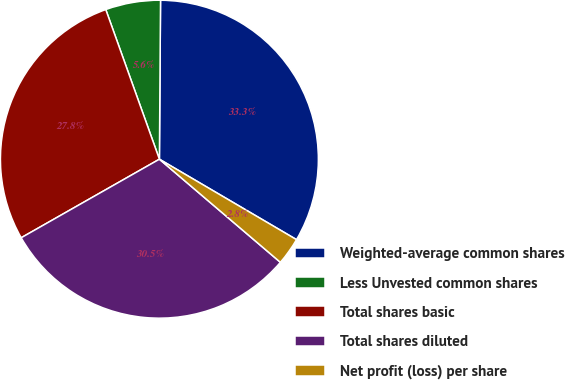<chart> <loc_0><loc_0><loc_500><loc_500><pie_chart><fcel>Weighted-average common shares<fcel>Less Unvested common shares<fcel>Total shares basic<fcel>Total shares diluted<fcel>Net profit (loss) per share<nl><fcel>33.33%<fcel>5.59%<fcel>27.75%<fcel>30.54%<fcel>2.79%<nl></chart> 